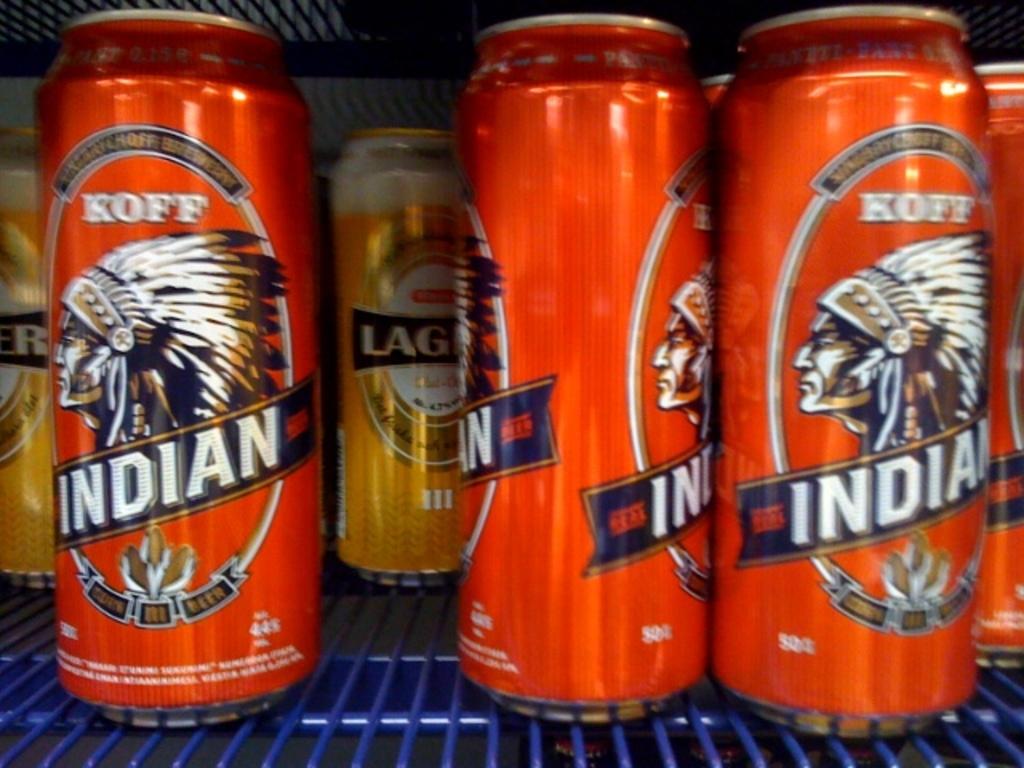What is the name of the beer with the indian head on it?
Offer a very short reply. Koff. 